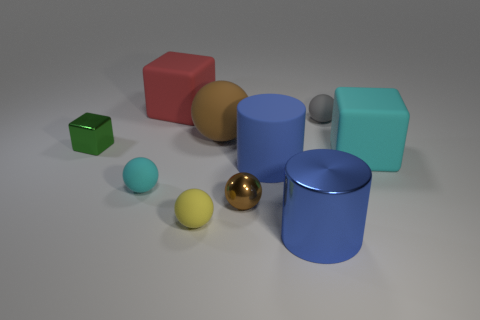Subtract 2 balls. How many balls are left? 3 Subtract all yellow balls. How many balls are left? 4 Subtract all blue spheres. Subtract all red cylinders. How many spheres are left? 5 Subtract all cylinders. How many objects are left? 8 Add 1 red objects. How many red objects exist? 2 Subtract 0 green balls. How many objects are left? 10 Subtract all tiny purple shiny cylinders. Subtract all big spheres. How many objects are left? 9 Add 8 small brown things. How many small brown things are left? 9 